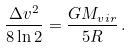Convert formula to latex. <formula><loc_0><loc_0><loc_500><loc_500>\frac { \Delta v ^ { 2 } } { 8 \ln 2 } = \frac { G M _ { v i r } } { 5 R } \, .</formula> 